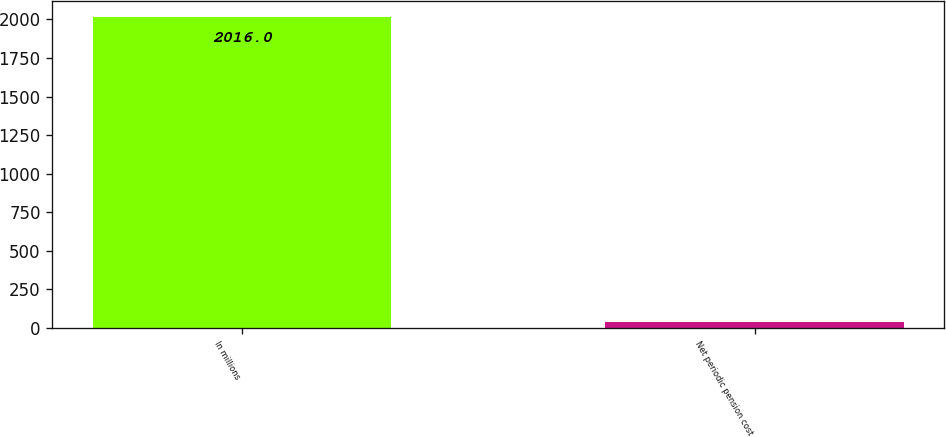<chart> <loc_0><loc_0><loc_500><loc_500><bar_chart><fcel>In millions<fcel>Net periodic pension cost<nl><fcel>2016<fcel>42<nl></chart> 